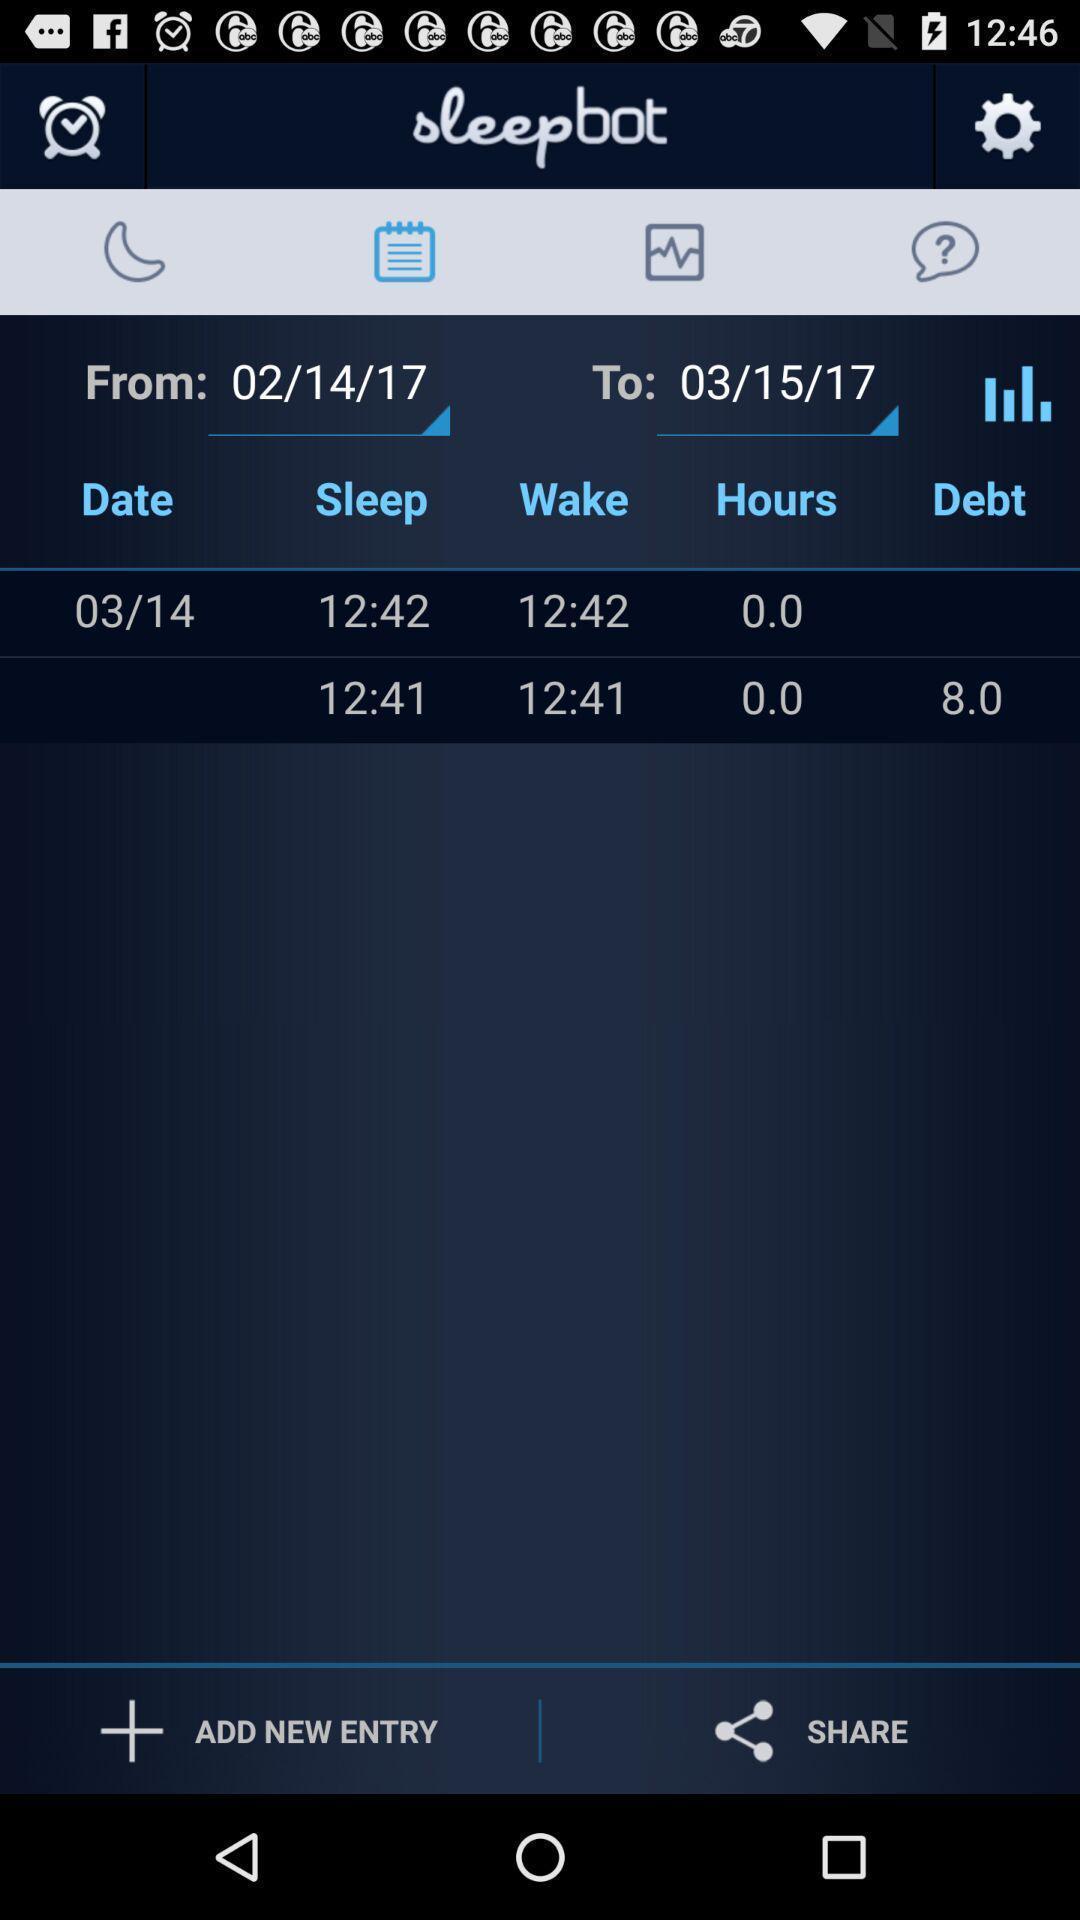Summarize the main components in this picture. Schedule of the alarm in the page. 